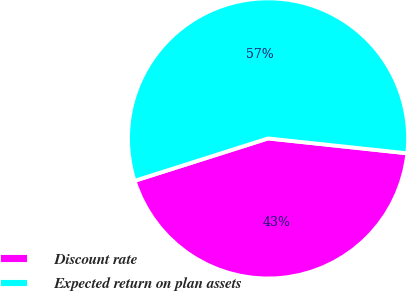<chart> <loc_0><loc_0><loc_500><loc_500><pie_chart><fcel>Discount rate<fcel>Expected return on plan assets<nl><fcel>43.41%<fcel>56.59%<nl></chart> 